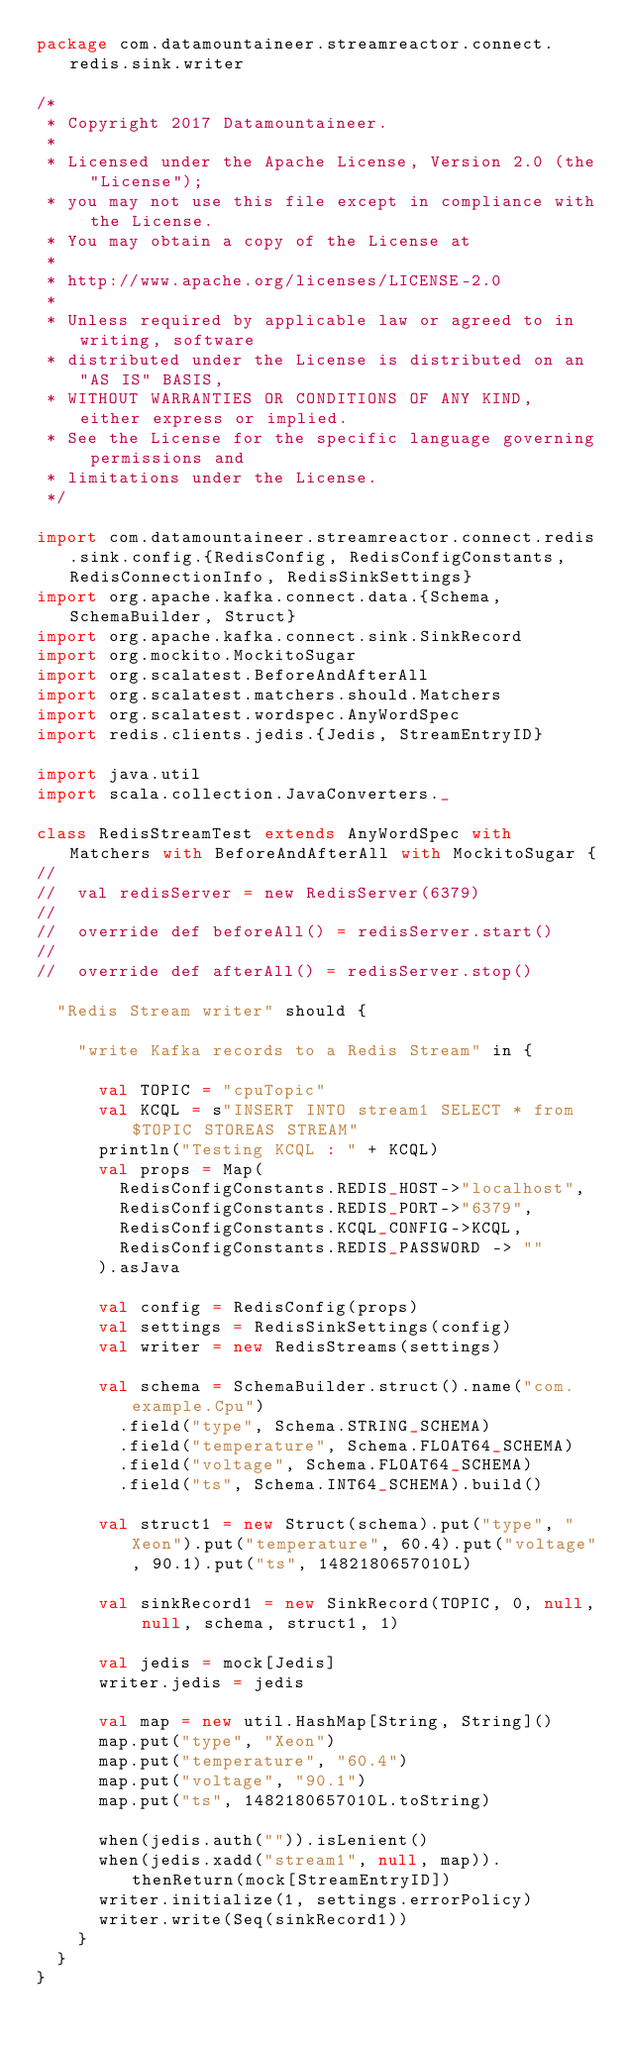Convert code to text. <code><loc_0><loc_0><loc_500><loc_500><_Scala_>package com.datamountaineer.streamreactor.connect.redis.sink.writer

/*
 * Copyright 2017 Datamountaineer.
 *
 * Licensed under the Apache License, Version 2.0 (the "License");
 * you may not use this file except in compliance with the License.
 * You may obtain a copy of the License at
 *
 * http://www.apache.org/licenses/LICENSE-2.0
 *
 * Unless required by applicable law or agreed to in writing, software
 * distributed under the License is distributed on an "AS IS" BASIS,
 * WITHOUT WARRANTIES OR CONDITIONS OF ANY KIND, either express or implied.
 * See the License for the specific language governing permissions and
 * limitations under the License.
 */

import com.datamountaineer.streamreactor.connect.redis.sink.config.{RedisConfig, RedisConfigConstants, RedisConnectionInfo, RedisSinkSettings}
import org.apache.kafka.connect.data.{Schema, SchemaBuilder, Struct}
import org.apache.kafka.connect.sink.SinkRecord
import org.mockito.MockitoSugar
import org.scalatest.BeforeAndAfterAll
import org.scalatest.matchers.should.Matchers
import org.scalatest.wordspec.AnyWordSpec
import redis.clients.jedis.{Jedis, StreamEntryID}

import java.util
import scala.collection.JavaConverters._

class RedisStreamTest extends AnyWordSpec with Matchers with BeforeAndAfterAll with MockitoSugar {
//
//  val redisServer = new RedisServer(6379)
//
//  override def beforeAll() = redisServer.start()
//
//  override def afterAll() = redisServer.stop()

  "Redis Stream writer" should {

    "write Kafka records to a Redis Stream" in {

      val TOPIC = "cpuTopic"
      val KCQL = s"INSERT INTO stream1 SELECT * from $TOPIC STOREAS STREAM"
      println("Testing KCQL : " + KCQL)
      val props = Map(
        RedisConfigConstants.REDIS_HOST->"localhost",
        RedisConfigConstants.REDIS_PORT->"6379",
        RedisConfigConstants.KCQL_CONFIG->KCQL,
        RedisConfigConstants.REDIS_PASSWORD -> ""
      ).asJava

      val config = RedisConfig(props)
      val settings = RedisSinkSettings(config)
      val writer = new RedisStreams(settings)

      val schema = SchemaBuilder.struct().name("com.example.Cpu")
        .field("type", Schema.STRING_SCHEMA)
        .field("temperature", Schema.FLOAT64_SCHEMA)
        .field("voltage", Schema.FLOAT64_SCHEMA)
        .field("ts", Schema.INT64_SCHEMA).build()

      val struct1 = new Struct(schema).put("type", "Xeon").put("temperature", 60.4).put("voltage", 90.1).put("ts", 1482180657010L)

      val sinkRecord1 = new SinkRecord(TOPIC, 0, null, null, schema, struct1, 1)

      val jedis = mock[Jedis]
      writer.jedis = jedis

      val map = new util.HashMap[String, String]()
      map.put("type", "Xeon")
      map.put("temperature", "60.4")
      map.put("voltage", "90.1")
      map.put("ts", 1482180657010L.toString)

      when(jedis.auth("")).isLenient()
      when(jedis.xadd("stream1", null, map)).thenReturn(mock[StreamEntryID])
      writer.initialize(1, settings.errorPolicy)
      writer.write(Seq(sinkRecord1))
    }
  }
}
</code> 